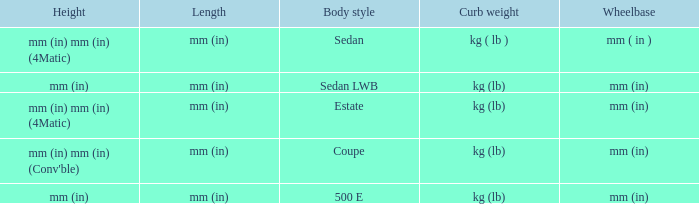Can you give me this table as a dict? {'header': ['Height', 'Length', 'Body style', 'Curb weight', 'Wheelbase'], 'rows': [['mm (in) mm (in) (4Matic)', 'mm (in)', 'Sedan', 'kg ( lb )', 'mm ( in )'], ['mm (in)', 'mm (in)', 'Sedan LWB', 'kg (lb)', 'mm (in)'], ['mm (in) mm (in) (4Matic)', 'mm (in)', 'Estate', 'kg (lb)', 'mm (in)'], ["mm (in) mm (in) (Conv'ble)", 'mm (in)', 'Coupe', 'kg (lb)', 'mm (in)'], ['mm (in)', 'mm (in)', '500 E', 'kg (lb)', 'mm (in)']]} What's the length of the model with Sedan body style? Mm (in). 